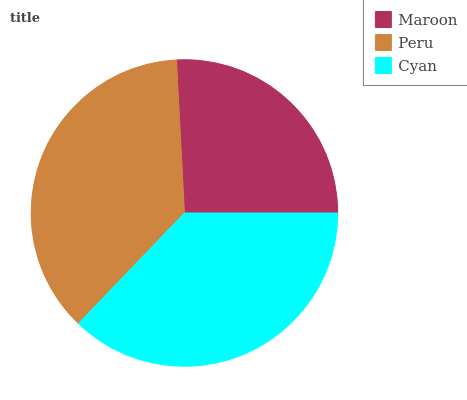Is Maroon the minimum?
Answer yes or no. Yes. Is Cyan the maximum?
Answer yes or no. Yes. Is Peru the minimum?
Answer yes or no. No. Is Peru the maximum?
Answer yes or no. No. Is Peru greater than Maroon?
Answer yes or no. Yes. Is Maroon less than Peru?
Answer yes or no. Yes. Is Maroon greater than Peru?
Answer yes or no. No. Is Peru less than Maroon?
Answer yes or no. No. Is Peru the high median?
Answer yes or no. Yes. Is Peru the low median?
Answer yes or no. Yes. Is Cyan the high median?
Answer yes or no. No. Is Cyan the low median?
Answer yes or no. No. 